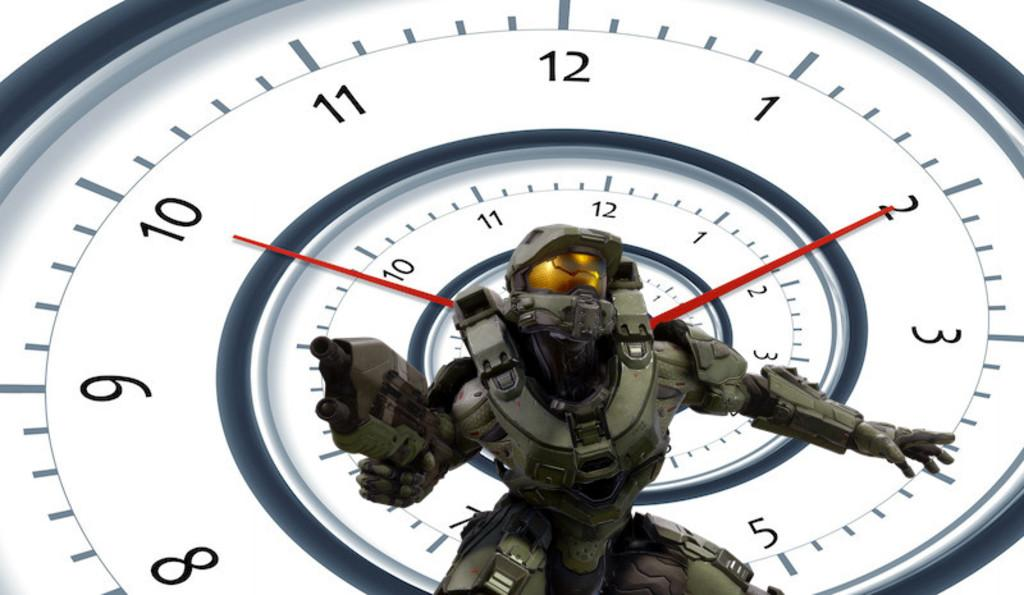<image>
Describe the image concisely. Cartoon character in front of a watch with the hands on the 10 and 2. 